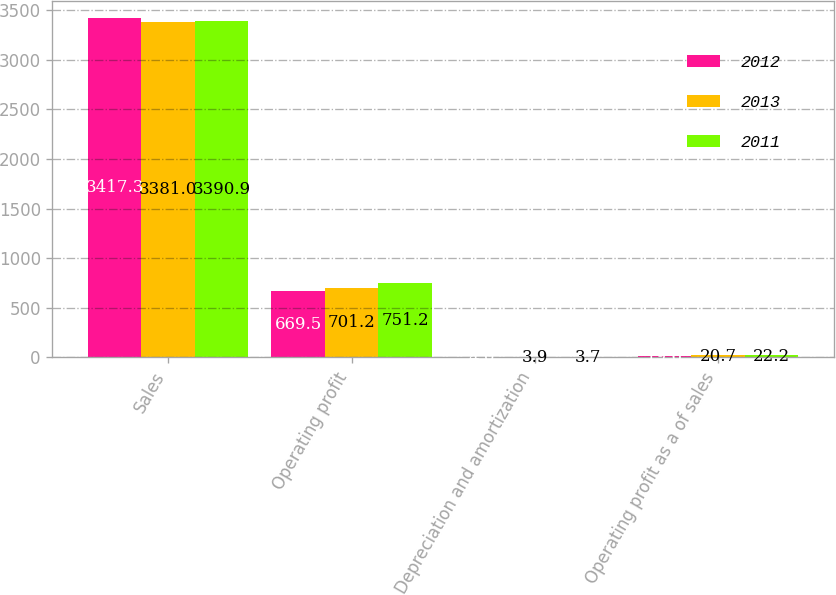Convert chart. <chart><loc_0><loc_0><loc_500><loc_500><stacked_bar_chart><ecel><fcel>Sales<fcel>Operating profit<fcel>Depreciation and amortization<fcel>Operating profit as a of sales<nl><fcel>2012<fcel>3417.3<fcel>669.5<fcel>4<fcel>19.6<nl><fcel>2013<fcel>3381<fcel>701.2<fcel>3.9<fcel>20.7<nl><fcel>2011<fcel>3390.9<fcel>751.2<fcel>3.7<fcel>22.2<nl></chart> 